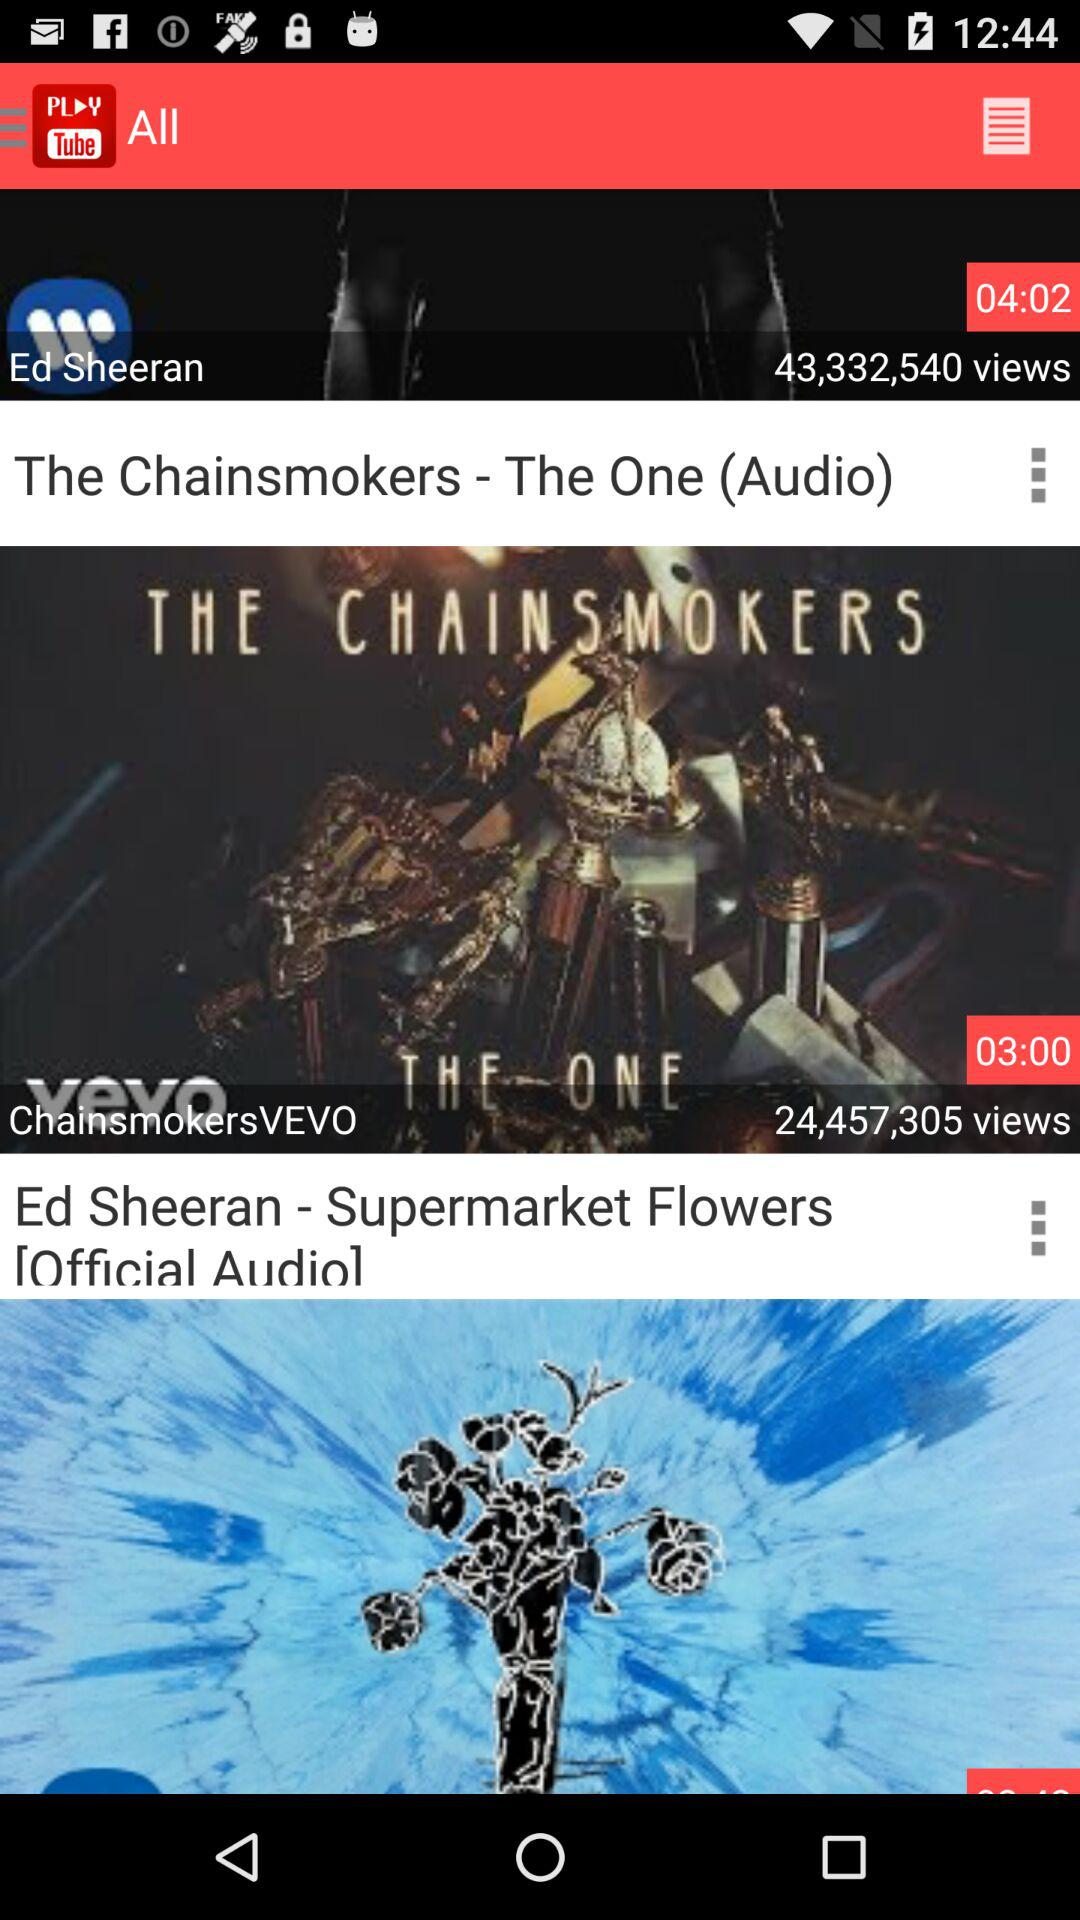How many more seconds is the video with the longest duration than the video with the shortest duration?
Answer the question using a single word or phrase. 62 